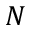Convert formula to latex. <formula><loc_0><loc_0><loc_500><loc_500>N</formula> 